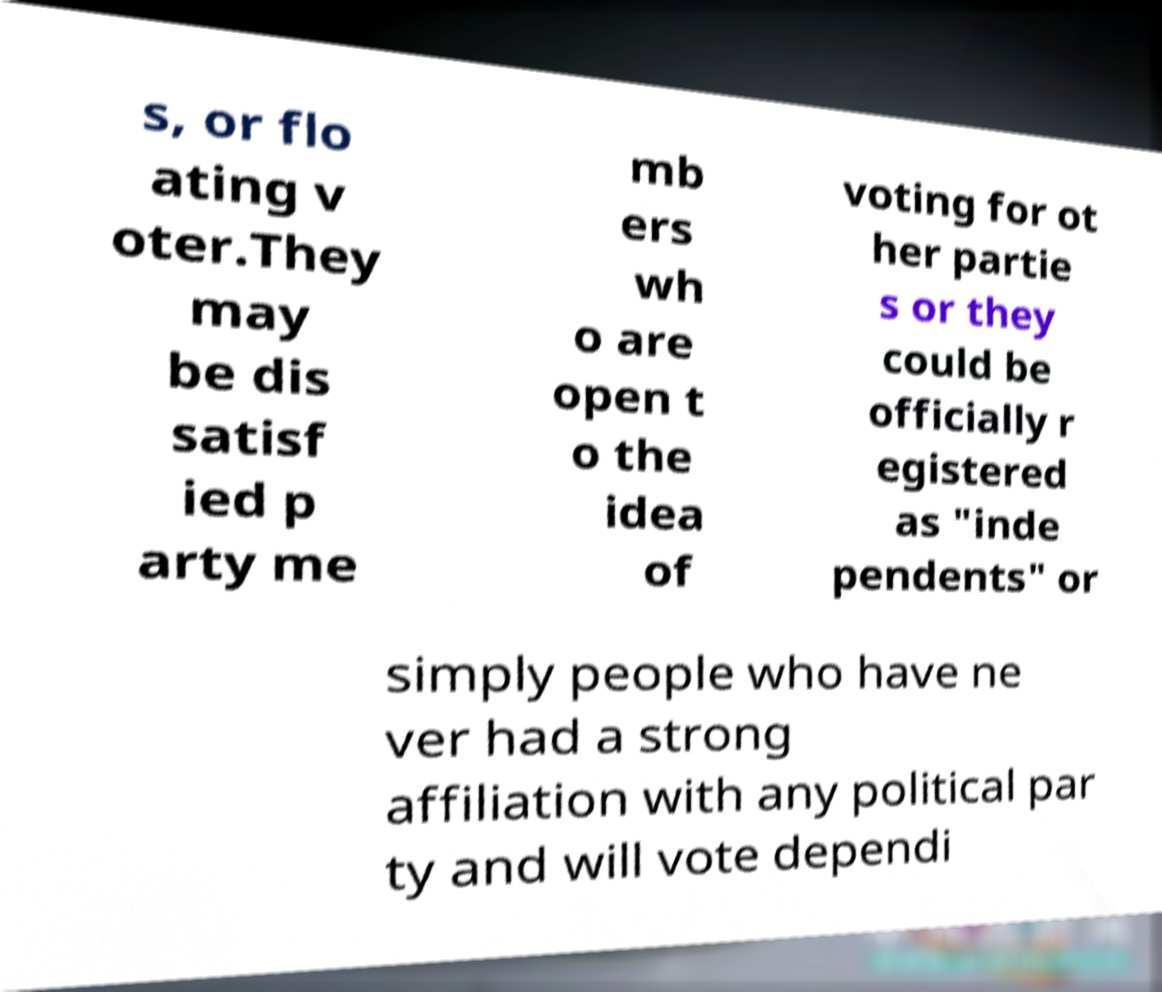Can you read and provide the text displayed in the image?This photo seems to have some interesting text. Can you extract and type it out for me? s, or flo ating v oter.They may be dis satisf ied p arty me mb ers wh o are open t o the idea of voting for ot her partie s or they could be officially r egistered as "inde pendents" or simply people who have ne ver had a strong affiliation with any political par ty and will vote dependi 